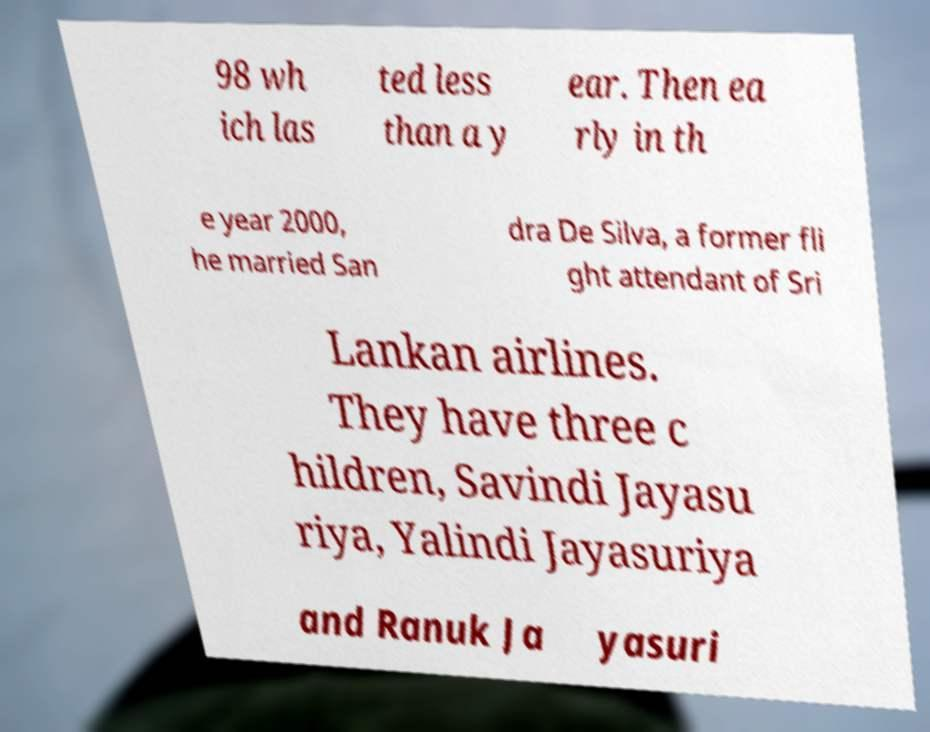What messages or text are displayed in this image? I need them in a readable, typed format. 98 wh ich las ted less than a y ear. Then ea rly in th e year 2000, he married San dra De Silva, a former fli ght attendant of Sri Lankan airlines. They have three c hildren, Savindi Jayasu riya, Yalindi Jayasuriya and Ranuk Ja yasuri 